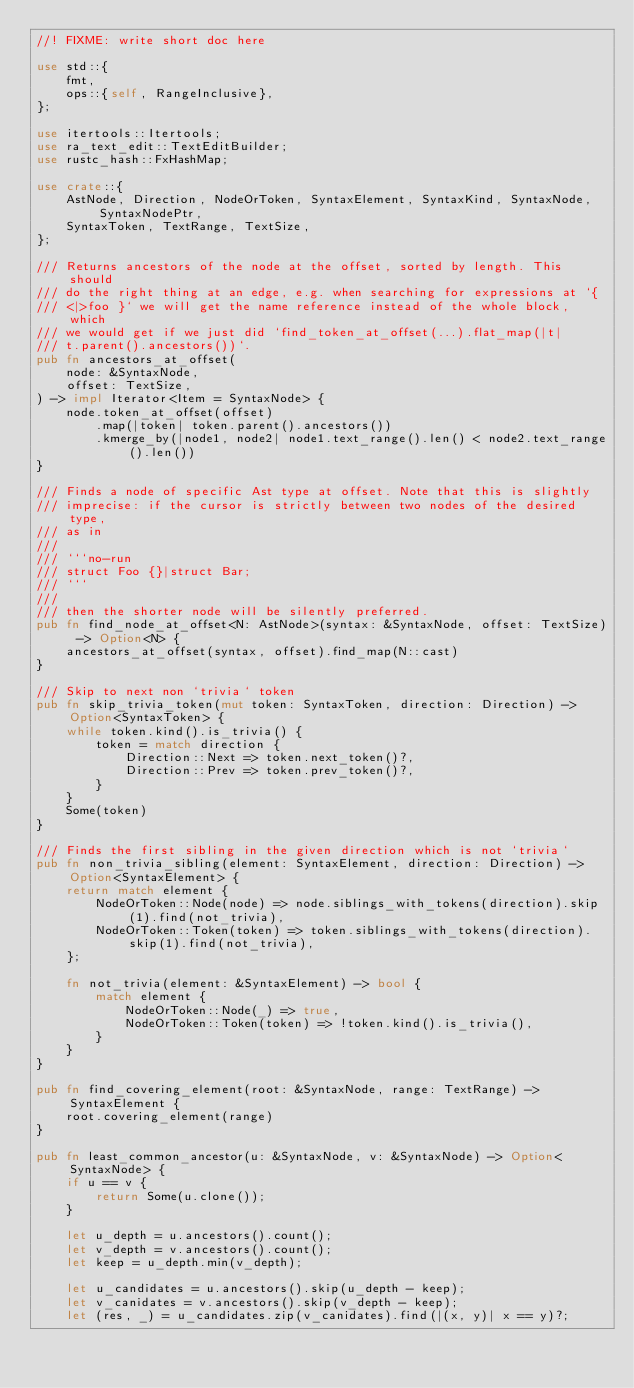Convert code to text. <code><loc_0><loc_0><loc_500><loc_500><_Rust_>//! FIXME: write short doc here

use std::{
    fmt,
    ops::{self, RangeInclusive},
};

use itertools::Itertools;
use ra_text_edit::TextEditBuilder;
use rustc_hash::FxHashMap;

use crate::{
    AstNode, Direction, NodeOrToken, SyntaxElement, SyntaxKind, SyntaxNode, SyntaxNodePtr,
    SyntaxToken, TextRange, TextSize,
};

/// Returns ancestors of the node at the offset, sorted by length. This should
/// do the right thing at an edge, e.g. when searching for expressions at `{
/// <|>foo }` we will get the name reference instead of the whole block, which
/// we would get if we just did `find_token_at_offset(...).flat_map(|t|
/// t.parent().ancestors())`.
pub fn ancestors_at_offset(
    node: &SyntaxNode,
    offset: TextSize,
) -> impl Iterator<Item = SyntaxNode> {
    node.token_at_offset(offset)
        .map(|token| token.parent().ancestors())
        .kmerge_by(|node1, node2| node1.text_range().len() < node2.text_range().len())
}

/// Finds a node of specific Ast type at offset. Note that this is slightly
/// imprecise: if the cursor is strictly between two nodes of the desired type,
/// as in
///
/// ```no-run
/// struct Foo {}|struct Bar;
/// ```
///
/// then the shorter node will be silently preferred.
pub fn find_node_at_offset<N: AstNode>(syntax: &SyntaxNode, offset: TextSize) -> Option<N> {
    ancestors_at_offset(syntax, offset).find_map(N::cast)
}

/// Skip to next non `trivia` token
pub fn skip_trivia_token(mut token: SyntaxToken, direction: Direction) -> Option<SyntaxToken> {
    while token.kind().is_trivia() {
        token = match direction {
            Direction::Next => token.next_token()?,
            Direction::Prev => token.prev_token()?,
        }
    }
    Some(token)
}

/// Finds the first sibling in the given direction which is not `trivia`
pub fn non_trivia_sibling(element: SyntaxElement, direction: Direction) -> Option<SyntaxElement> {
    return match element {
        NodeOrToken::Node(node) => node.siblings_with_tokens(direction).skip(1).find(not_trivia),
        NodeOrToken::Token(token) => token.siblings_with_tokens(direction).skip(1).find(not_trivia),
    };

    fn not_trivia(element: &SyntaxElement) -> bool {
        match element {
            NodeOrToken::Node(_) => true,
            NodeOrToken::Token(token) => !token.kind().is_trivia(),
        }
    }
}

pub fn find_covering_element(root: &SyntaxNode, range: TextRange) -> SyntaxElement {
    root.covering_element(range)
}

pub fn least_common_ancestor(u: &SyntaxNode, v: &SyntaxNode) -> Option<SyntaxNode> {
    if u == v {
        return Some(u.clone());
    }

    let u_depth = u.ancestors().count();
    let v_depth = v.ancestors().count();
    let keep = u_depth.min(v_depth);

    let u_candidates = u.ancestors().skip(u_depth - keep);
    let v_canidates = v.ancestors().skip(v_depth - keep);
    let (res, _) = u_candidates.zip(v_canidates).find(|(x, y)| x == y)?;</code> 